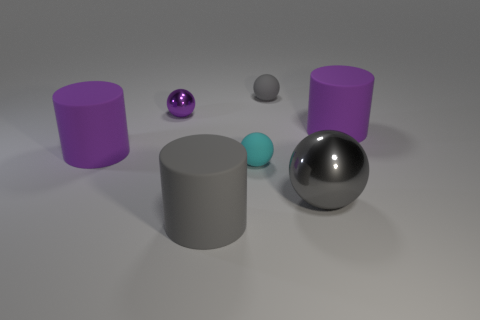Subtract all purple rubber cylinders. How many cylinders are left? 1 Add 1 metal balls. How many objects exist? 8 Subtract all gray cylinders. How many cylinders are left? 2 Subtract all balls. How many objects are left? 3 Subtract all large things. Subtract all cyan objects. How many objects are left? 2 Add 4 purple objects. How many purple objects are left? 7 Add 4 brown cylinders. How many brown cylinders exist? 4 Subtract 0 gray cubes. How many objects are left? 7 Subtract 3 balls. How many balls are left? 1 Subtract all purple cylinders. Subtract all red cubes. How many cylinders are left? 1 